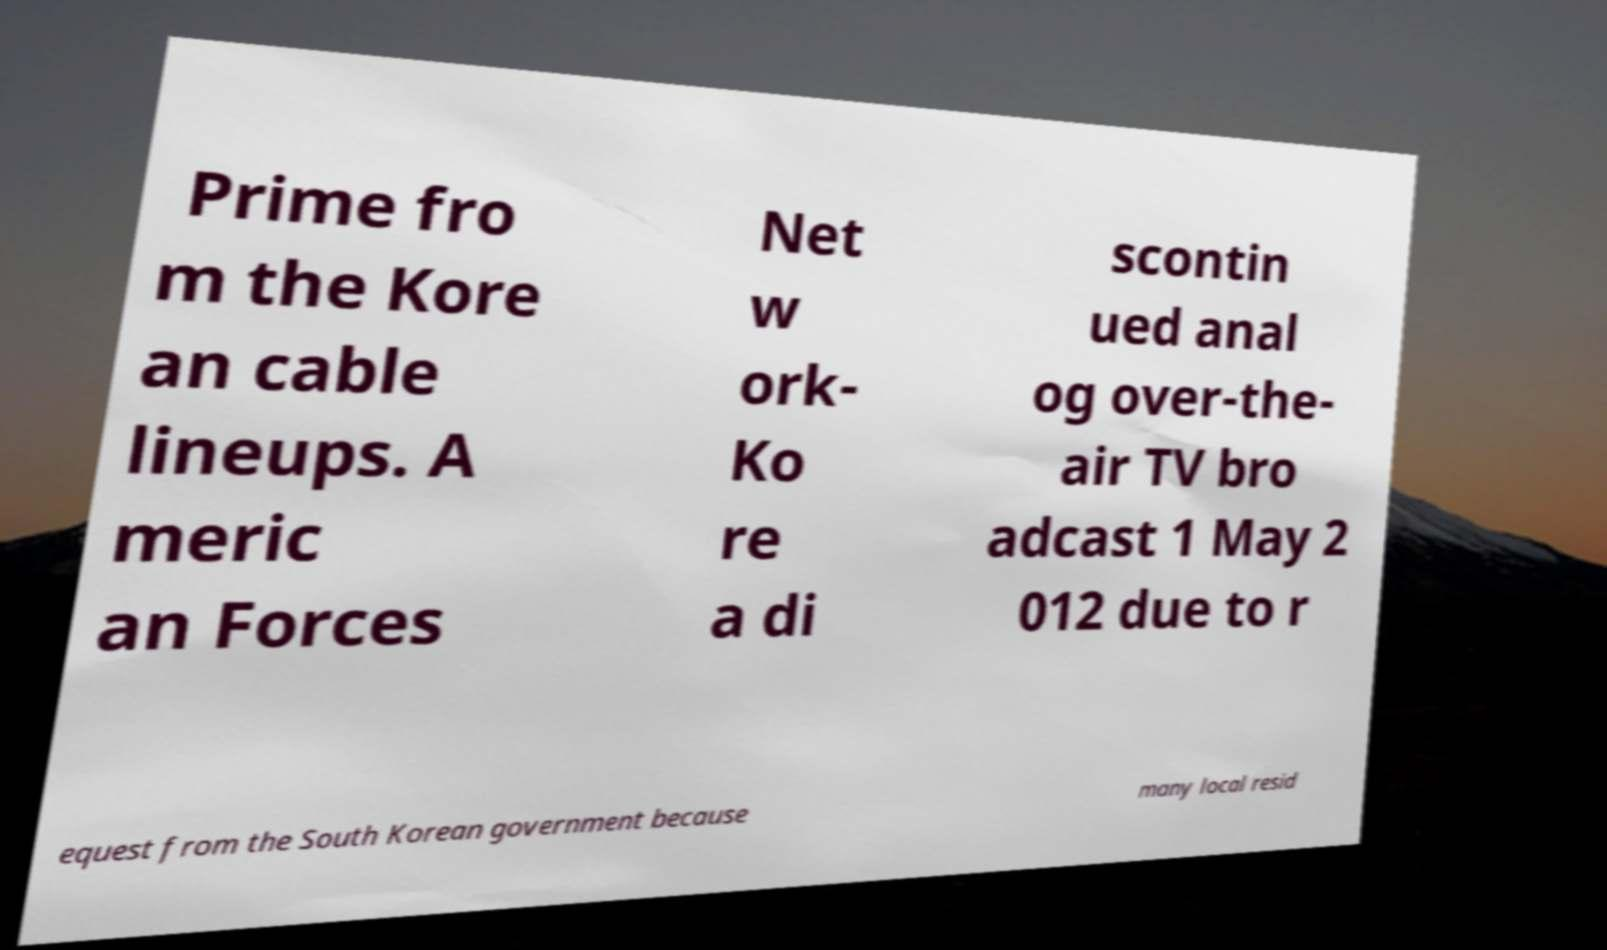What messages or text are displayed in this image? I need them in a readable, typed format. Prime fro m the Kore an cable lineups. A meric an Forces Net w ork- Ko re a di scontin ued anal og over-the- air TV bro adcast 1 May 2 012 due to r equest from the South Korean government because many local resid 